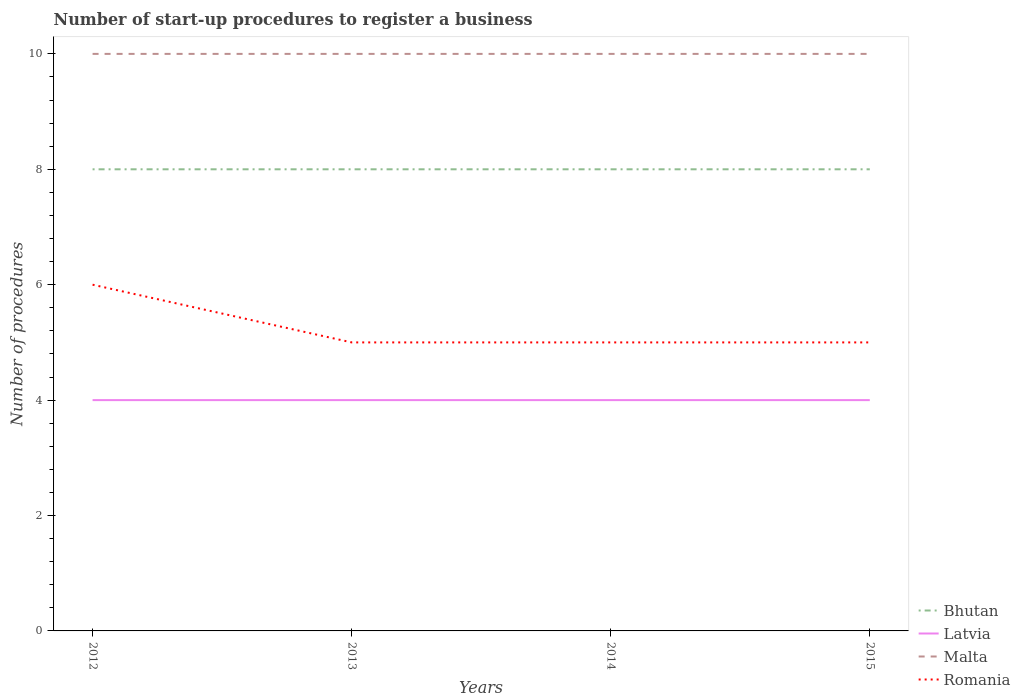Does the line corresponding to Latvia intersect with the line corresponding to Bhutan?
Your response must be concise. No. Is the number of lines equal to the number of legend labels?
Your response must be concise. Yes. Across all years, what is the maximum number of procedures required to register a business in Romania?
Provide a short and direct response. 5. What is the total number of procedures required to register a business in Romania in the graph?
Ensure brevity in your answer.  0. What is the difference between the highest and the lowest number of procedures required to register a business in Bhutan?
Keep it short and to the point. 0. Does the graph contain any zero values?
Your answer should be compact. No. Where does the legend appear in the graph?
Ensure brevity in your answer.  Bottom right. How are the legend labels stacked?
Provide a short and direct response. Vertical. What is the title of the graph?
Your response must be concise. Number of start-up procedures to register a business. Does "Bulgaria" appear as one of the legend labels in the graph?
Your answer should be very brief. No. What is the label or title of the X-axis?
Offer a very short reply. Years. What is the label or title of the Y-axis?
Keep it short and to the point. Number of procedures. What is the Number of procedures in Bhutan in 2012?
Your response must be concise. 8. What is the Number of procedures in Malta in 2012?
Your response must be concise. 10. What is the Number of procedures in Romania in 2012?
Provide a succinct answer. 6. What is the Number of procedures of Bhutan in 2013?
Give a very brief answer. 8. What is the Number of procedures in Romania in 2014?
Provide a succinct answer. 5. What is the Number of procedures in Bhutan in 2015?
Your response must be concise. 8. Across all years, what is the maximum Number of procedures in Bhutan?
Ensure brevity in your answer.  8. Across all years, what is the maximum Number of procedures of Romania?
Your answer should be very brief. 6. Across all years, what is the minimum Number of procedures of Malta?
Your answer should be very brief. 10. What is the total Number of procedures of Malta in the graph?
Your answer should be compact. 40. What is the total Number of procedures of Romania in the graph?
Offer a very short reply. 21. What is the difference between the Number of procedures of Bhutan in 2012 and that in 2013?
Provide a succinct answer. 0. What is the difference between the Number of procedures in Latvia in 2012 and that in 2014?
Keep it short and to the point. 0. What is the difference between the Number of procedures in Malta in 2012 and that in 2014?
Make the answer very short. 0. What is the difference between the Number of procedures of Bhutan in 2012 and that in 2015?
Offer a very short reply. 0. What is the difference between the Number of procedures of Romania in 2012 and that in 2015?
Give a very brief answer. 1. What is the difference between the Number of procedures of Latvia in 2013 and that in 2014?
Give a very brief answer. 0. What is the difference between the Number of procedures in Bhutan in 2013 and that in 2015?
Make the answer very short. 0. What is the difference between the Number of procedures in Latvia in 2013 and that in 2015?
Offer a terse response. 0. What is the difference between the Number of procedures of Malta in 2013 and that in 2015?
Your answer should be compact. 0. What is the difference between the Number of procedures of Bhutan in 2014 and that in 2015?
Provide a short and direct response. 0. What is the difference between the Number of procedures of Malta in 2014 and that in 2015?
Offer a very short reply. 0. What is the difference between the Number of procedures of Romania in 2014 and that in 2015?
Provide a short and direct response. 0. What is the difference between the Number of procedures of Bhutan in 2012 and the Number of procedures of Latvia in 2013?
Offer a terse response. 4. What is the difference between the Number of procedures in Bhutan in 2012 and the Number of procedures in Romania in 2013?
Your answer should be compact. 3. What is the difference between the Number of procedures in Latvia in 2012 and the Number of procedures in Malta in 2013?
Your answer should be compact. -6. What is the difference between the Number of procedures of Latvia in 2012 and the Number of procedures of Romania in 2013?
Your answer should be compact. -1. What is the difference between the Number of procedures of Bhutan in 2012 and the Number of procedures of Latvia in 2014?
Your response must be concise. 4. What is the difference between the Number of procedures in Bhutan in 2012 and the Number of procedures in Romania in 2014?
Make the answer very short. 3. What is the difference between the Number of procedures in Malta in 2012 and the Number of procedures in Romania in 2014?
Your answer should be compact. 5. What is the difference between the Number of procedures in Latvia in 2012 and the Number of procedures in Romania in 2015?
Your answer should be very brief. -1. What is the difference between the Number of procedures in Bhutan in 2013 and the Number of procedures in Latvia in 2014?
Your response must be concise. 4. What is the difference between the Number of procedures in Bhutan in 2013 and the Number of procedures in Malta in 2014?
Ensure brevity in your answer.  -2. What is the difference between the Number of procedures in Bhutan in 2013 and the Number of procedures in Romania in 2014?
Ensure brevity in your answer.  3. What is the difference between the Number of procedures of Bhutan in 2013 and the Number of procedures of Malta in 2015?
Offer a very short reply. -2. What is the difference between the Number of procedures in Bhutan in 2013 and the Number of procedures in Romania in 2015?
Give a very brief answer. 3. What is the difference between the Number of procedures of Malta in 2013 and the Number of procedures of Romania in 2015?
Ensure brevity in your answer.  5. What is the difference between the Number of procedures in Bhutan in 2014 and the Number of procedures in Latvia in 2015?
Provide a succinct answer. 4. What is the difference between the Number of procedures in Bhutan in 2014 and the Number of procedures in Malta in 2015?
Ensure brevity in your answer.  -2. What is the difference between the Number of procedures in Bhutan in 2014 and the Number of procedures in Romania in 2015?
Offer a terse response. 3. What is the difference between the Number of procedures of Latvia in 2014 and the Number of procedures of Malta in 2015?
Give a very brief answer. -6. What is the average Number of procedures in Bhutan per year?
Your answer should be compact. 8. What is the average Number of procedures in Latvia per year?
Your response must be concise. 4. What is the average Number of procedures of Romania per year?
Keep it short and to the point. 5.25. In the year 2012, what is the difference between the Number of procedures in Bhutan and Number of procedures in Malta?
Give a very brief answer. -2. In the year 2012, what is the difference between the Number of procedures of Latvia and Number of procedures of Malta?
Give a very brief answer. -6. In the year 2012, what is the difference between the Number of procedures of Latvia and Number of procedures of Romania?
Give a very brief answer. -2. In the year 2013, what is the difference between the Number of procedures in Bhutan and Number of procedures in Malta?
Give a very brief answer. -2. In the year 2013, what is the difference between the Number of procedures of Bhutan and Number of procedures of Romania?
Ensure brevity in your answer.  3. In the year 2013, what is the difference between the Number of procedures of Malta and Number of procedures of Romania?
Make the answer very short. 5. In the year 2014, what is the difference between the Number of procedures in Bhutan and Number of procedures in Latvia?
Your answer should be compact. 4. In the year 2014, what is the difference between the Number of procedures of Latvia and Number of procedures of Romania?
Offer a terse response. -1. In the year 2014, what is the difference between the Number of procedures in Malta and Number of procedures in Romania?
Offer a terse response. 5. In the year 2015, what is the difference between the Number of procedures in Bhutan and Number of procedures in Romania?
Provide a succinct answer. 3. In the year 2015, what is the difference between the Number of procedures in Latvia and Number of procedures in Malta?
Your answer should be very brief. -6. In the year 2015, what is the difference between the Number of procedures in Latvia and Number of procedures in Romania?
Provide a succinct answer. -1. What is the ratio of the Number of procedures of Bhutan in 2012 to that in 2013?
Your response must be concise. 1. What is the ratio of the Number of procedures of Latvia in 2012 to that in 2013?
Ensure brevity in your answer.  1. What is the ratio of the Number of procedures of Romania in 2012 to that in 2013?
Provide a short and direct response. 1.2. What is the ratio of the Number of procedures in Malta in 2012 to that in 2014?
Make the answer very short. 1. What is the ratio of the Number of procedures of Latvia in 2013 to that in 2014?
Your answer should be very brief. 1. What is the ratio of the Number of procedures of Romania in 2013 to that in 2014?
Your answer should be very brief. 1. What is the ratio of the Number of procedures of Latvia in 2013 to that in 2015?
Ensure brevity in your answer.  1. What is the ratio of the Number of procedures of Bhutan in 2014 to that in 2015?
Your response must be concise. 1. What is the ratio of the Number of procedures in Latvia in 2014 to that in 2015?
Keep it short and to the point. 1. What is the ratio of the Number of procedures of Malta in 2014 to that in 2015?
Ensure brevity in your answer.  1. What is the difference between the highest and the lowest Number of procedures of Bhutan?
Offer a terse response. 0. What is the difference between the highest and the lowest Number of procedures in Latvia?
Your response must be concise. 0. What is the difference between the highest and the lowest Number of procedures in Malta?
Provide a short and direct response. 0. What is the difference between the highest and the lowest Number of procedures in Romania?
Give a very brief answer. 1. 